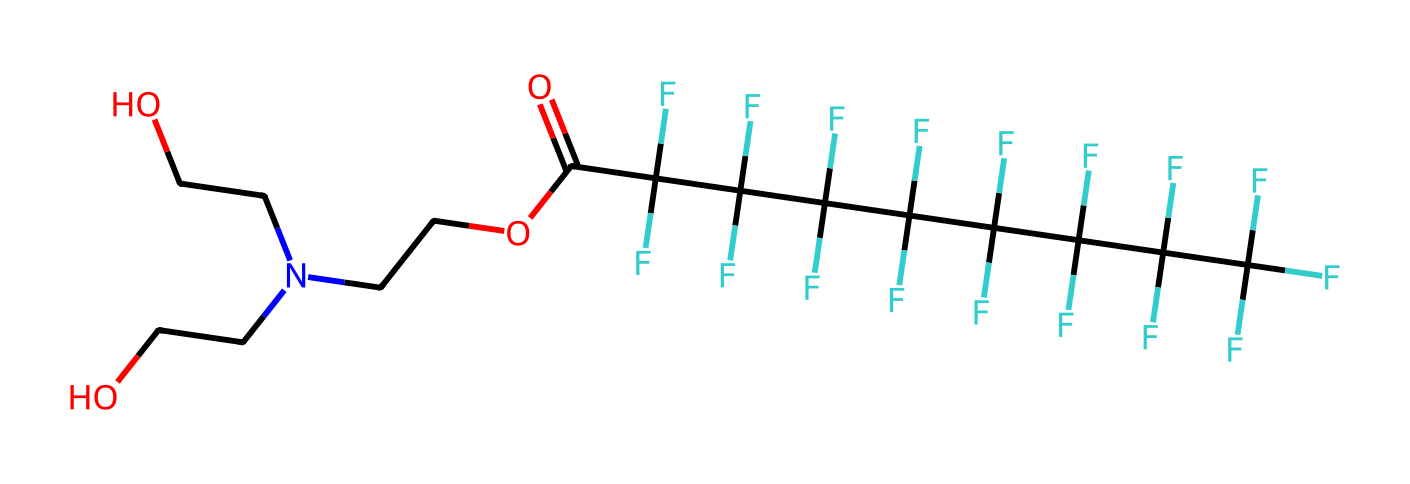What is the primary functional group present in this compound? The compound contains a carboxylic acid functional group, indicated by the presence of the -COOH (or -C(=O)O) structure, which is recognized as a characteristic group of carboxylic acids.
Answer: carboxylic acid How many fluorine atoms are in this molecule? By analyzing the chemical structure, it is evident that there are multiple -CF3 (trifluoromethyl) groups, which contribute a total of 9 fluorine atoms in the entire structure.
Answer: nine Does this molecule have hydrophilic or hydrophobic properties? The presence of multiple fluorine atoms (perfluorinated sections) strongly suggests hydrophobic behavior, as fluorinated compounds typically repel water, while the presence of a hydrophilic functional group (carboxylic acid) indicates some affinity for water. However, the overall structure favors hydrophobic interactions.
Answer: hydrophobic What type of application is this chemical likely used for? Given its chemical structure, particularly the water-repellent characteristics imparted by the fluorinated sections, this molecule can be used as a treatment for outdoor apparel and gear to enhance their waterproofing capabilities.
Answer: waterproofing treatment What characteristic of the compound contributes to its surface tension lowering ability? The presence of surfactant-like features, including both hydrophobic (fluorine groups) and hydrophilic (carboxylic acid) characteristics, allows the compound to interact with water, reducing its surface tension, which is a key property of detergents.
Answer: surfactant-like features 